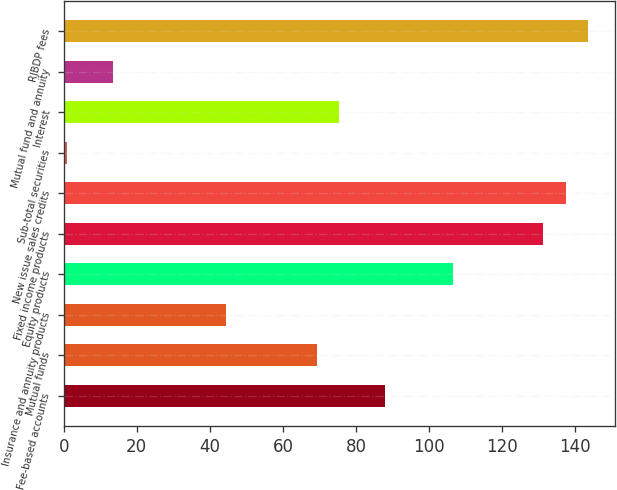<chart> <loc_0><loc_0><loc_500><loc_500><bar_chart><fcel>Fee-based accounts<fcel>Mutual funds<fcel>Insurance and annuity products<fcel>Equity products<fcel>Fixed income products<fcel>New issue sales credits<fcel>Sub-total securities<fcel>Interest<fcel>Mutual fund and annuity<fcel>RJBDP fees<nl><fcel>87.8<fcel>69.2<fcel>44.4<fcel>106.4<fcel>131.2<fcel>137.4<fcel>1<fcel>75.4<fcel>13.4<fcel>143.6<nl></chart> 